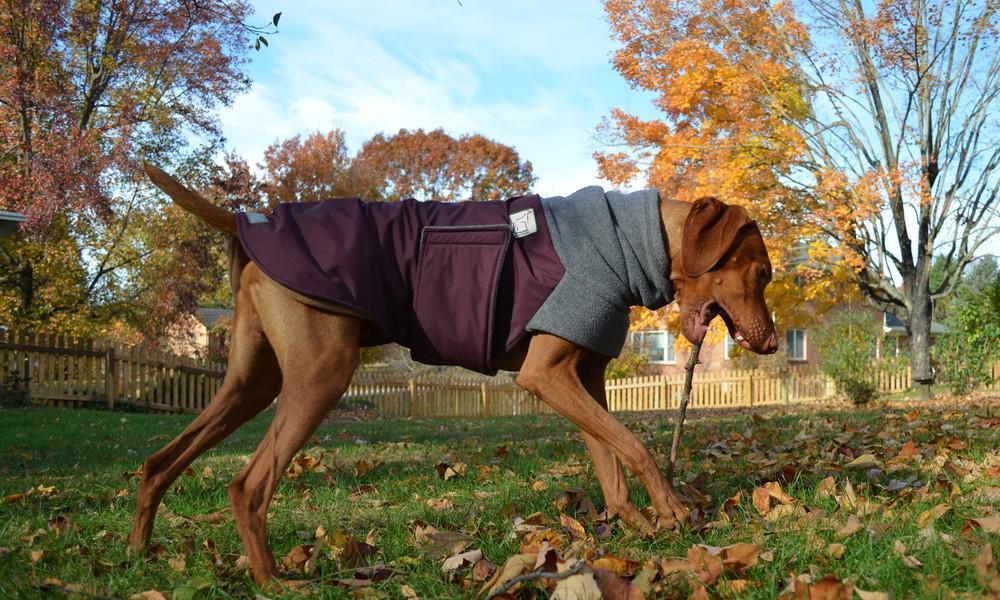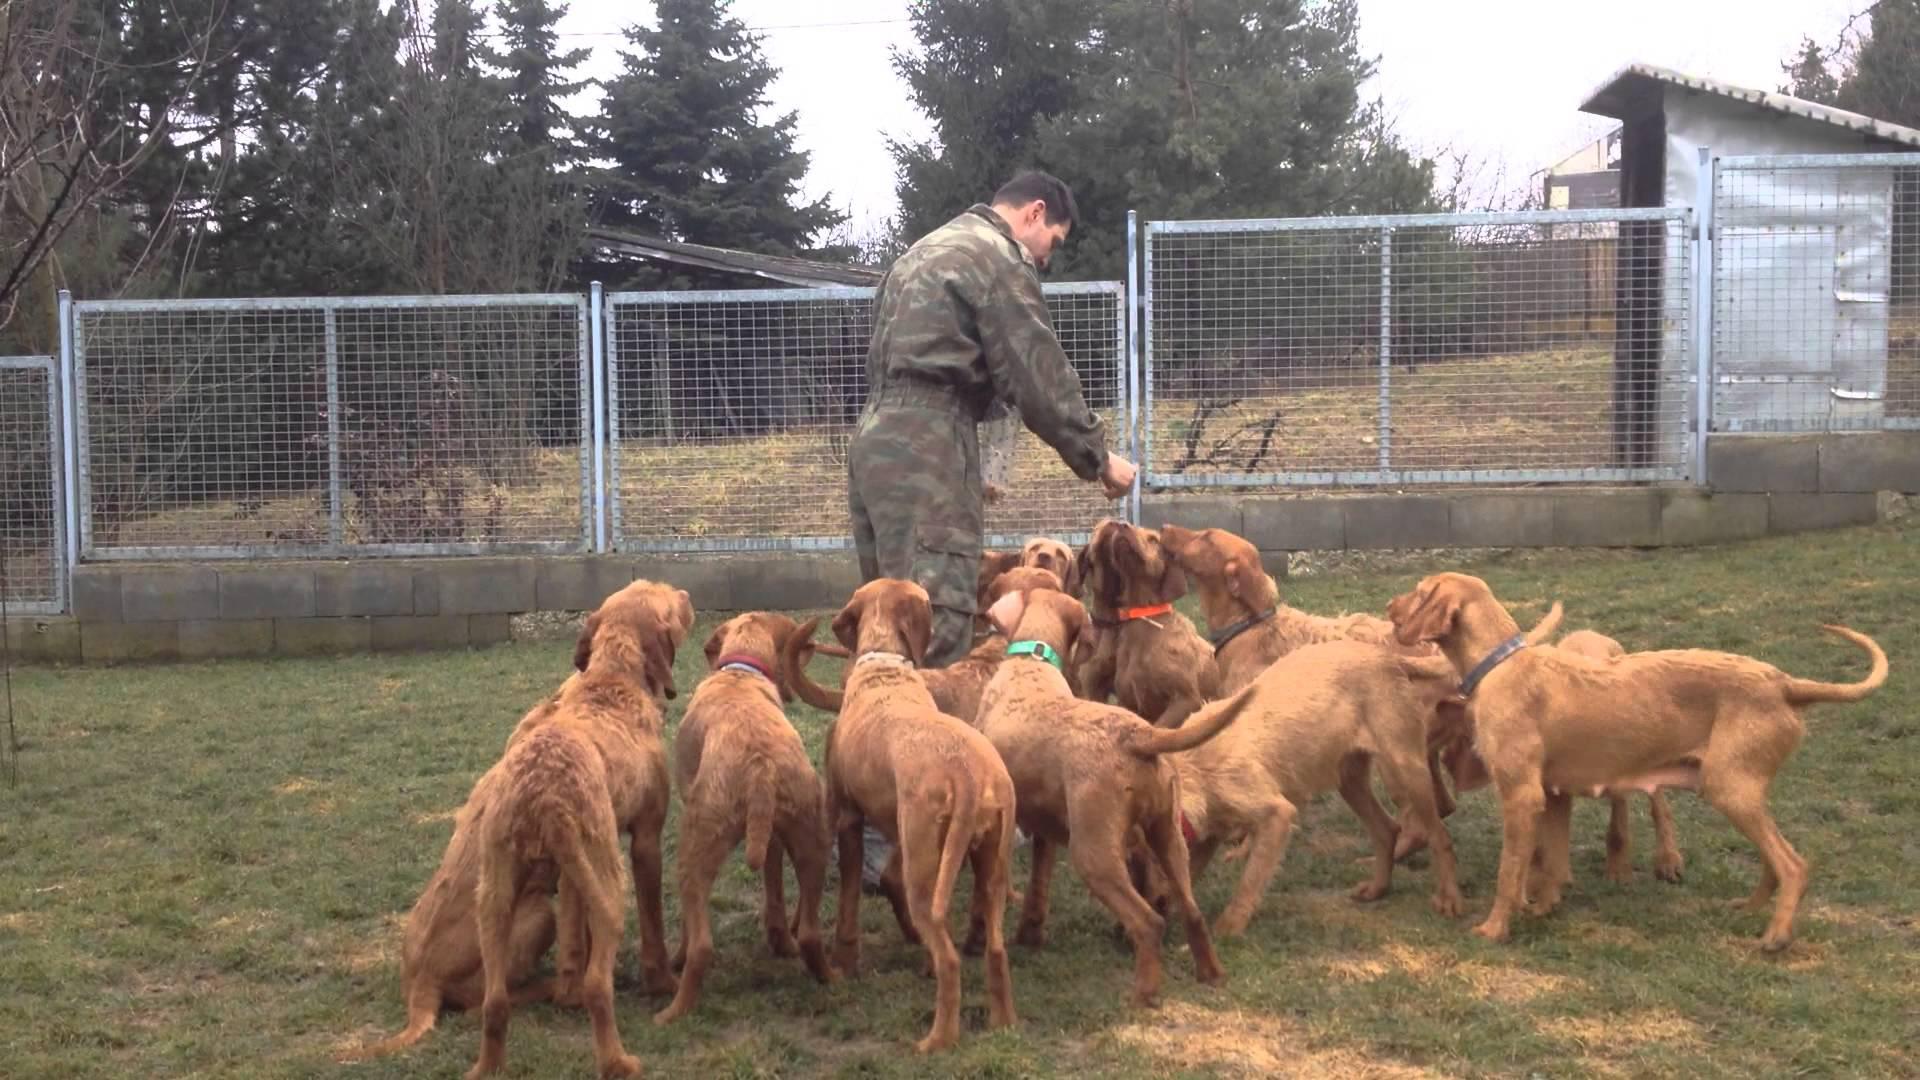The first image is the image on the left, the second image is the image on the right. For the images displayed, is the sentence "One dog is wearing an item on it's back and the rest are only wearing collars." factually correct? Answer yes or no. Yes. The first image is the image on the left, the second image is the image on the right. For the images displayed, is the sentence "There are three dogs sitting." factually correct? Answer yes or no. No. 